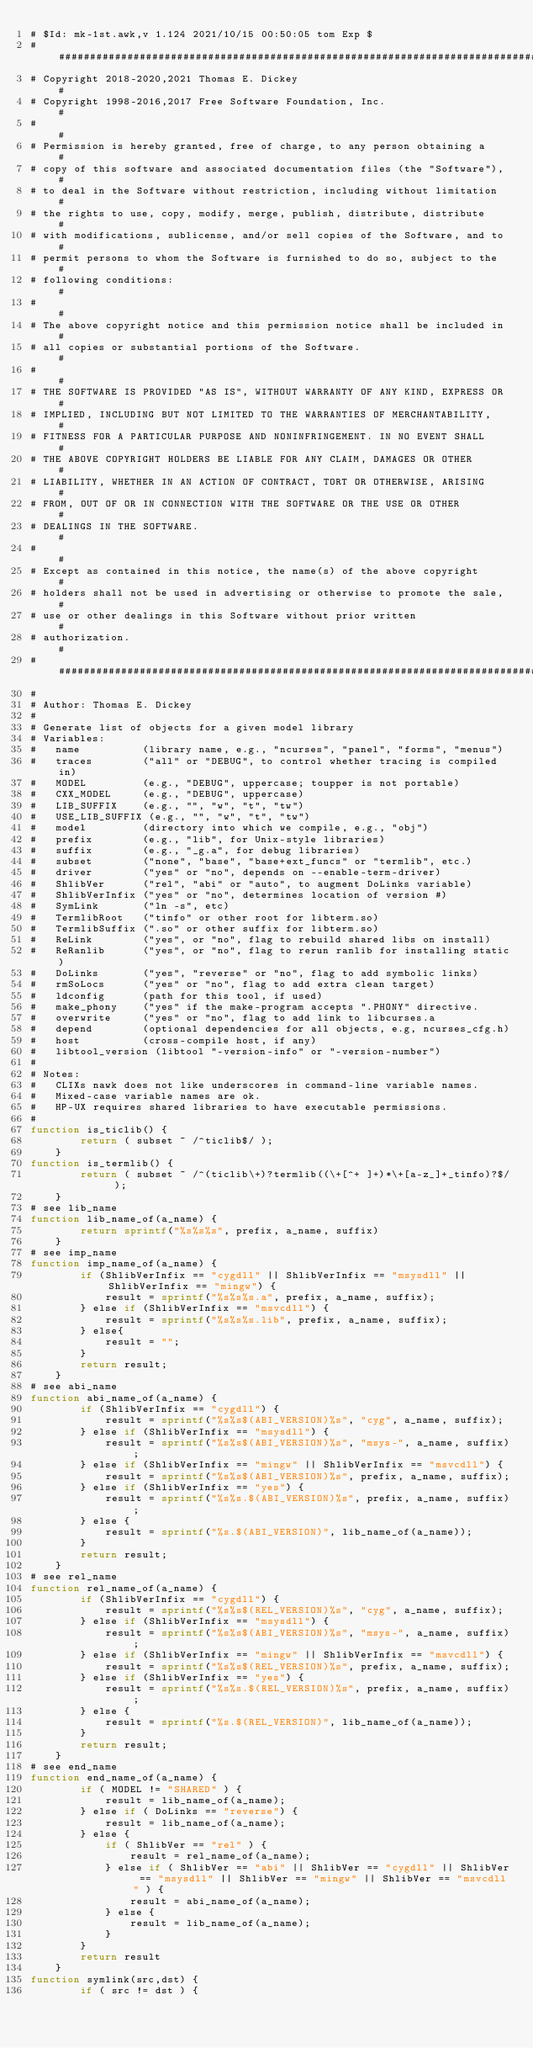<code> <loc_0><loc_0><loc_500><loc_500><_Awk_># $Id: mk-1st.awk,v 1.124 2021/10/15 00:50:05 tom Exp $
##############################################################################
# Copyright 2018-2020,2021 Thomas E. Dickey                                  #
# Copyright 1998-2016,2017 Free Software Foundation, Inc.                    #
#                                                                            #
# Permission is hereby granted, free of charge, to any person obtaining a    #
# copy of this software and associated documentation files (the "Software"), #
# to deal in the Software without restriction, including without limitation  #
# the rights to use, copy, modify, merge, publish, distribute, distribute    #
# with modifications, sublicense, and/or sell copies of the Software, and to #
# permit persons to whom the Software is furnished to do so, subject to the  #
# following conditions:                                                      #
#                                                                            #
# The above copyright notice and this permission notice shall be included in #
# all copies or substantial portions of the Software.                        #
#                                                                            #
# THE SOFTWARE IS PROVIDED "AS IS", WITHOUT WARRANTY OF ANY KIND, EXPRESS OR #
# IMPLIED, INCLUDING BUT NOT LIMITED TO THE WARRANTIES OF MERCHANTABILITY,   #
# FITNESS FOR A PARTICULAR PURPOSE AND NONINFRINGEMENT. IN NO EVENT SHALL    #
# THE ABOVE COPYRIGHT HOLDERS BE LIABLE FOR ANY CLAIM, DAMAGES OR OTHER      #
# LIABILITY, WHETHER IN AN ACTION OF CONTRACT, TORT OR OTHERWISE, ARISING    #
# FROM, OUT OF OR IN CONNECTION WITH THE SOFTWARE OR THE USE OR OTHER        #
# DEALINGS IN THE SOFTWARE.                                                  #
#                                                                            #
# Except as contained in this notice, the name(s) of the above copyright     #
# holders shall not be used in advertising or otherwise to promote the sale, #
# use or other dealings in this Software without prior written               #
# authorization.                                                             #
##############################################################################
#
# Author: Thomas E. Dickey
#
# Generate list of objects for a given model library
# Variables:
#	name		  (library name, e.g., "ncurses", "panel", "forms", "menus")
#	traces		  ("all" or "DEBUG", to control whether tracing is compiled in)
#	MODEL		  (e.g., "DEBUG", uppercase; toupper is not portable)
#	CXX_MODEL	  (e.g., "DEBUG", uppercase)
#	LIB_SUFFIX	  (e.g., "", "w", "t", "tw")
#	USE_LIB_SUFFIX (e.g., "", "w", "t", "tw")
#	model		  (directory into which we compile, e.g., "obj")
#	prefix		  (e.g., "lib", for Unix-style libraries)
#	suffix		  (e.g., "_g.a", for debug libraries)
#	subset		  ("none", "base", "base+ext_funcs" or "termlib", etc.)
#	driver		  ("yes" or "no", depends on --enable-term-driver)
#	ShlibVer	  ("rel", "abi" or "auto", to augment DoLinks variable)
#	ShlibVerInfix ("yes" or "no", determines location of version #)
#	SymLink		  ("ln -s", etc)
#	TermlibRoot	  ("tinfo" or other root for libterm.so)
#	TermlibSuffix (".so" or other suffix for libterm.so)
#	ReLink		  ("yes", or "no", flag to rebuild shared libs on install)
#	ReRanlib	  ("yes", or "no", flag to rerun ranlib for installing static)
#	DoLinks		  ("yes", "reverse" or "no", flag to add symbolic links)
#	rmSoLocs	  ("yes" or "no", flag to add extra clean target)
#	ldconfig	  (path for this tool, if used)
#	make_phony    ("yes" if the make-program accepts ".PHONY" directive.
#	overwrite	  ("yes" or "no", flag to add link to libcurses.a
#	depend		  (optional dependencies for all objects, e.g, ncurses_cfg.h)
#	host		  (cross-compile host, if any)
#	libtool_version (libtool "-version-info" or "-version-number")
#
# Notes:
#	CLIXs nawk does not like underscores in command-line variable names.
#	Mixed-case variable names are ok.
#	HP-UX requires shared libraries to have executable permissions.
#
function is_ticlib() {
		return ( subset ~ /^ticlib$/ );
	}
function is_termlib() {
		return ( subset ~ /^(ticlib\+)?termlib((\+[^+ ]+)*\+[a-z_]+_tinfo)?$/ );
	}
# see lib_name
function lib_name_of(a_name) {
		return sprintf("%s%s%s", prefix, a_name, suffix)
	}
# see imp_name
function imp_name_of(a_name) {
		if (ShlibVerInfix == "cygdll" || ShlibVerInfix == "msysdll" || ShlibVerInfix == "mingw") {
			result = sprintf("%s%s%s.a", prefix, a_name, suffix);
		} else if (ShlibVerInfix == "msvcdll") {
			result = sprintf("%s%s%s.lib", prefix, a_name, suffix);
		} else{
			result = "";
		}
		return result;
	}
# see abi_name
function abi_name_of(a_name) {
		if (ShlibVerInfix == "cygdll") {
			result = sprintf("%s%s$(ABI_VERSION)%s", "cyg", a_name, suffix);
		} else if (ShlibVerInfix == "msysdll") {
			result = sprintf("%s%s$(ABI_VERSION)%s", "msys-", a_name, suffix);
		} else if (ShlibVerInfix == "mingw" || ShlibVerInfix == "msvcdll") {
			result = sprintf("%s%s$(ABI_VERSION)%s", prefix, a_name, suffix);
		} else if (ShlibVerInfix == "yes") {
			result = sprintf("%s%s.$(ABI_VERSION)%s", prefix, a_name, suffix);
		} else {
			result = sprintf("%s.$(ABI_VERSION)", lib_name_of(a_name));
		}
		return result;
	}
# see rel_name
function rel_name_of(a_name) {
		if (ShlibVerInfix == "cygdll") {
			result = sprintf("%s%s$(REL_VERSION)%s", "cyg", a_name, suffix);
		} else if (ShlibVerInfix == "msysdll") {
			result = sprintf("%s%s$(ABI_VERSION)%s", "msys-", a_name, suffix);
		} else if (ShlibVerInfix == "mingw" || ShlibVerInfix == "msvcdll") {
			result = sprintf("%s%s$(REL_VERSION)%s", prefix, a_name, suffix);
		} else if (ShlibVerInfix == "yes") {
			result = sprintf("%s%s.$(REL_VERSION)%s", prefix, a_name, suffix);
		} else {
			result = sprintf("%s.$(REL_VERSION)", lib_name_of(a_name));
		}
		return result;
	}
# see end_name
function end_name_of(a_name) {
		if ( MODEL != "SHARED" ) {
			result = lib_name_of(a_name);
		} else if ( DoLinks == "reverse") {
			result = lib_name_of(a_name);
		} else {
			if ( ShlibVer == "rel" ) {
				result = rel_name_of(a_name);
			} else if ( ShlibVer == "abi" || ShlibVer == "cygdll" || ShlibVer == "msysdll" || ShlibVer == "mingw" || ShlibVer == "msvcdll" ) {
				result = abi_name_of(a_name);
			} else {
				result = lib_name_of(a_name);
			}
		}
		return result
	}
function symlink(src,dst) {
		if ( src != dst ) {</code> 